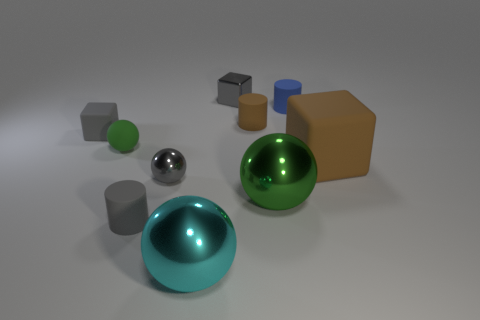The cyan thing that is made of the same material as the big green thing is what size?
Provide a short and direct response. Large. What is the size of the brown block?
Give a very brief answer. Large. Do the brown block and the brown rubber cylinder have the same size?
Offer a very short reply. No. There is a green ball that is right of the green rubber ball; is its size the same as the gray cube left of the rubber ball?
Ensure brevity in your answer.  No. Is the color of the rubber sphere the same as the large metallic ball that is right of the big cyan metallic sphere?
Ensure brevity in your answer.  Yes. How many small rubber cylinders are in front of the green ball that is in front of the large brown object?
Offer a terse response. 1. What is the object that is in front of the rubber thing that is in front of the thing to the right of the blue cylinder made of?
Provide a succinct answer. Metal. What is the material of the big object that is both on the right side of the small gray metal cube and to the left of the big matte object?
Offer a terse response. Metal. What number of gray metal objects are the same shape as the large cyan object?
Your response must be concise. 1. There is a sphere in front of the large sphere on the right side of the tiny brown cylinder; what is its size?
Your response must be concise. Large. 